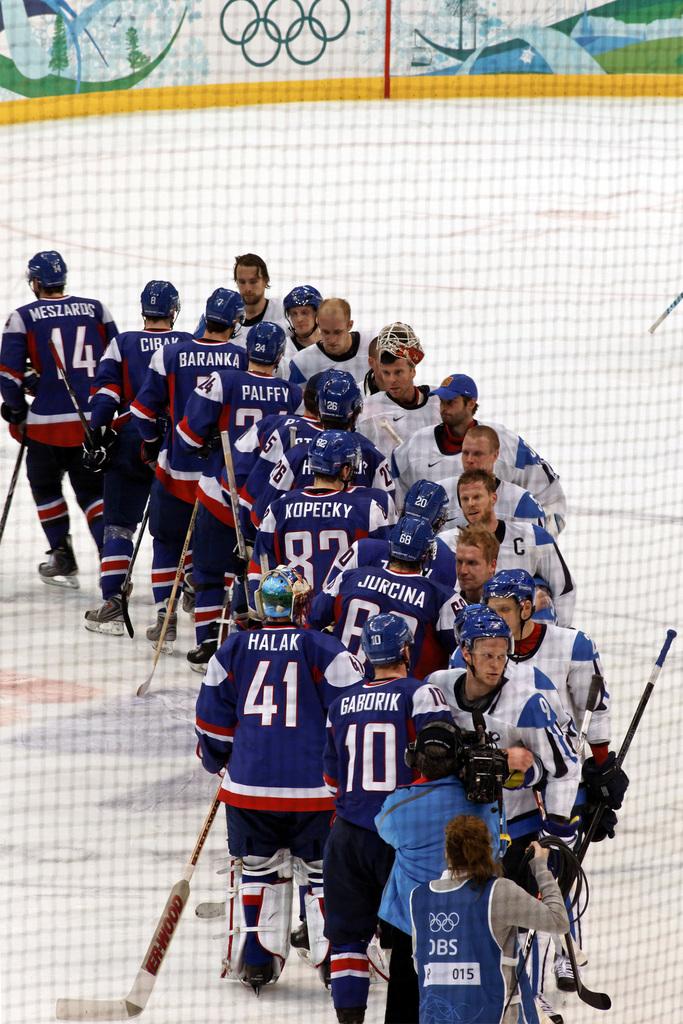What is the name of player 41?
Your response must be concise. Halak. 